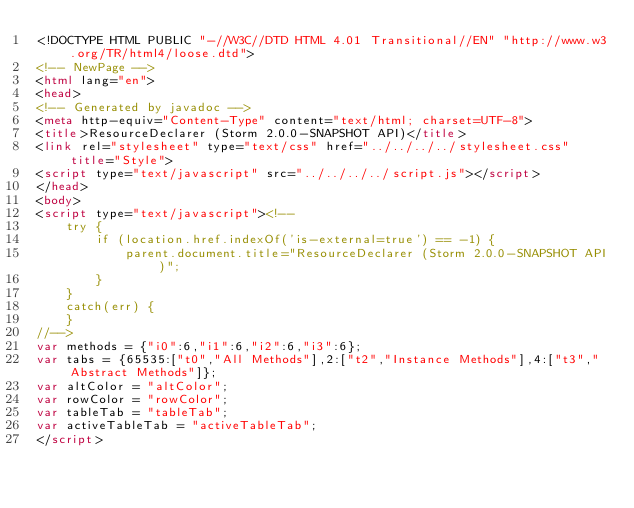<code> <loc_0><loc_0><loc_500><loc_500><_HTML_><!DOCTYPE HTML PUBLIC "-//W3C//DTD HTML 4.01 Transitional//EN" "http://www.w3.org/TR/html4/loose.dtd">
<!-- NewPage -->
<html lang="en">
<head>
<!-- Generated by javadoc -->
<meta http-equiv="Content-Type" content="text/html; charset=UTF-8">
<title>ResourceDeclarer (Storm 2.0.0-SNAPSHOT API)</title>
<link rel="stylesheet" type="text/css" href="../../../../stylesheet.css" title="Style">
<script type="text/javascript" src="../../../../script.js"></script>
</head>
<body>
<script type="text/javascript"><!--
    try {
        if (location.href.indexOf('is-external=true') == -1) {
            parent.document.title="ResourceDeclarer (Storm 2.0.0-SNAPSHOT API)";
        }
    }
    catch(err) {
    }
//-->
var methods = {"i0":6,"i1":6,"i2":6,"i3":6};
var tabs = {65535:["t0","All Methods"],2:["t2","Instance Methods"],4:["t3","Abstract Methods"]};
var altColor = "altColor";
var rowColor = "rowColor";
var tableTab = "tableTab";
var activeTableTab = "activeTableTab";
</script></code> 